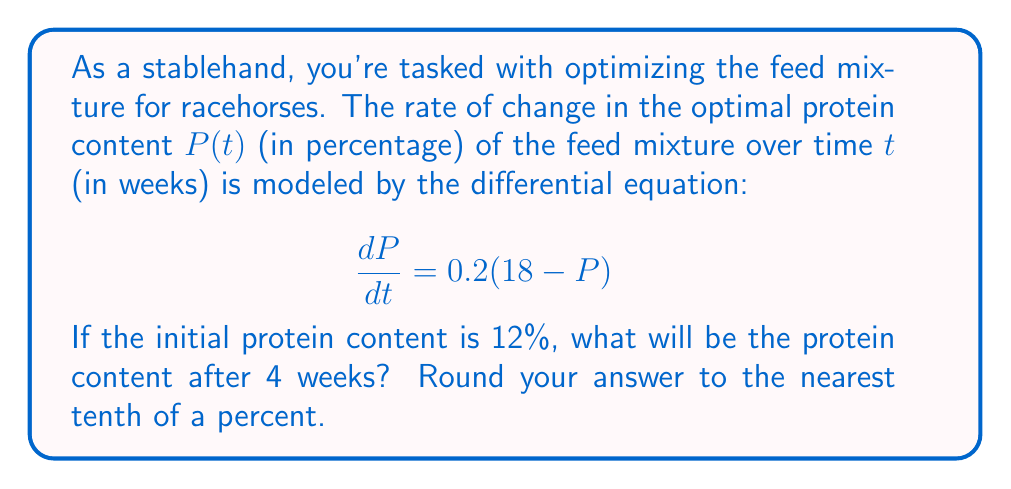Teach me how to tackle this problem. Let's solve this first-order differential equation step by step:

1) The given differential equation is:
   $$\frac{dP}{dt} = 0.2(18 - P)$$

2) This is a separable equation. Let's rearrange it:
   $$\frac{dP}{18 - P} = 0.2dt$$

3) Integrate both sides:
   $$\int \frac{dP}{18 - P} = \int 0.2dt$$

4) Solve the left side:
   $$-\ln|18 - P| = 0.2t + C$$

5) Apply the initial condition: at $t=0$, $P=12$
   $$-\ln|18 - 12| = 0.2(0) + C$$
   $$-\ln(6) = C$$

6) Substitute this back into the general solution:
   $$-\ln|18 - P| = 0.2t - \ln(6)$$

7) Solve for $P$:
   $$\ln|18 - P| = \ln(6) - 0.2t$$
   $$|18 - P| = 6e^{-0.2t}$$
   $$18 - P = 6e^{-0.2t}$$
   $$P = 18 - 6e^{-0.2t}$$

8) Now, we can find $P$ at $t=4$:
   $$P(4) = 18 - 6e^{-0.2(4)}$$
   $$P(4) = 18 - 6e^{-0.8}$$
   $$P(4) \approx 16.7$$

9) Rounding to the nearest tenth:
   $$P(4) \approx 16.7\%$$
Answer: 16.7% 